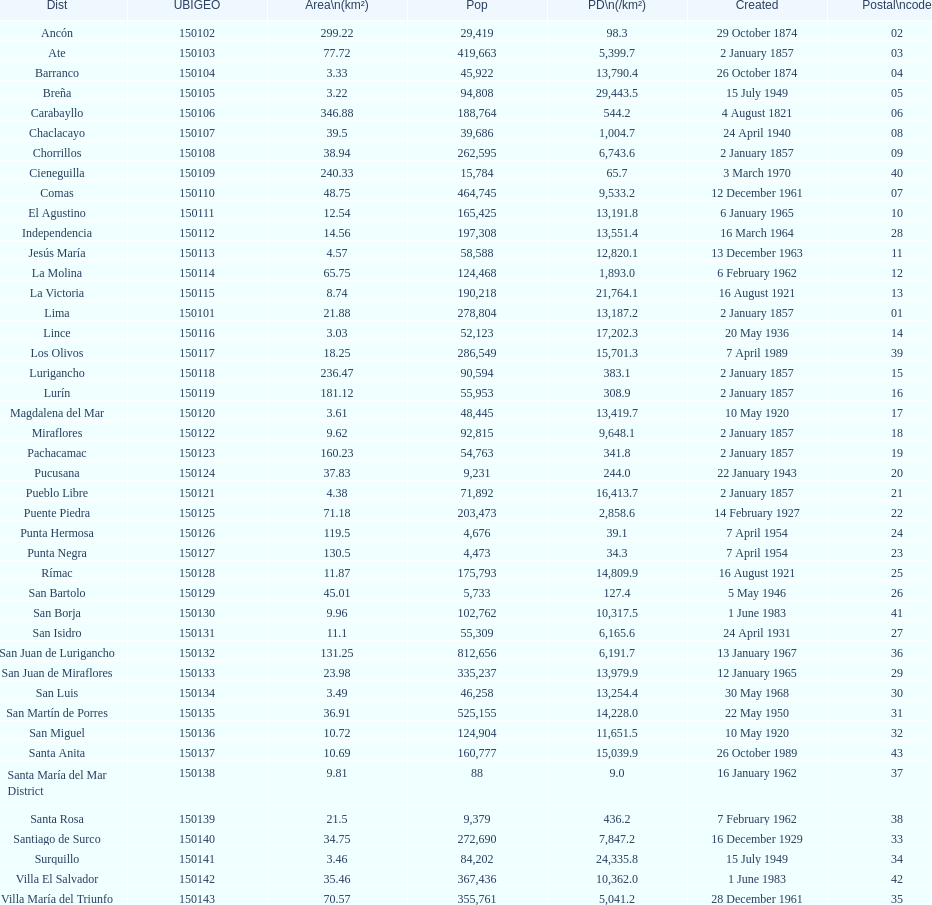Which is the largest district in terms of population? San Juan de Lurigancho. 